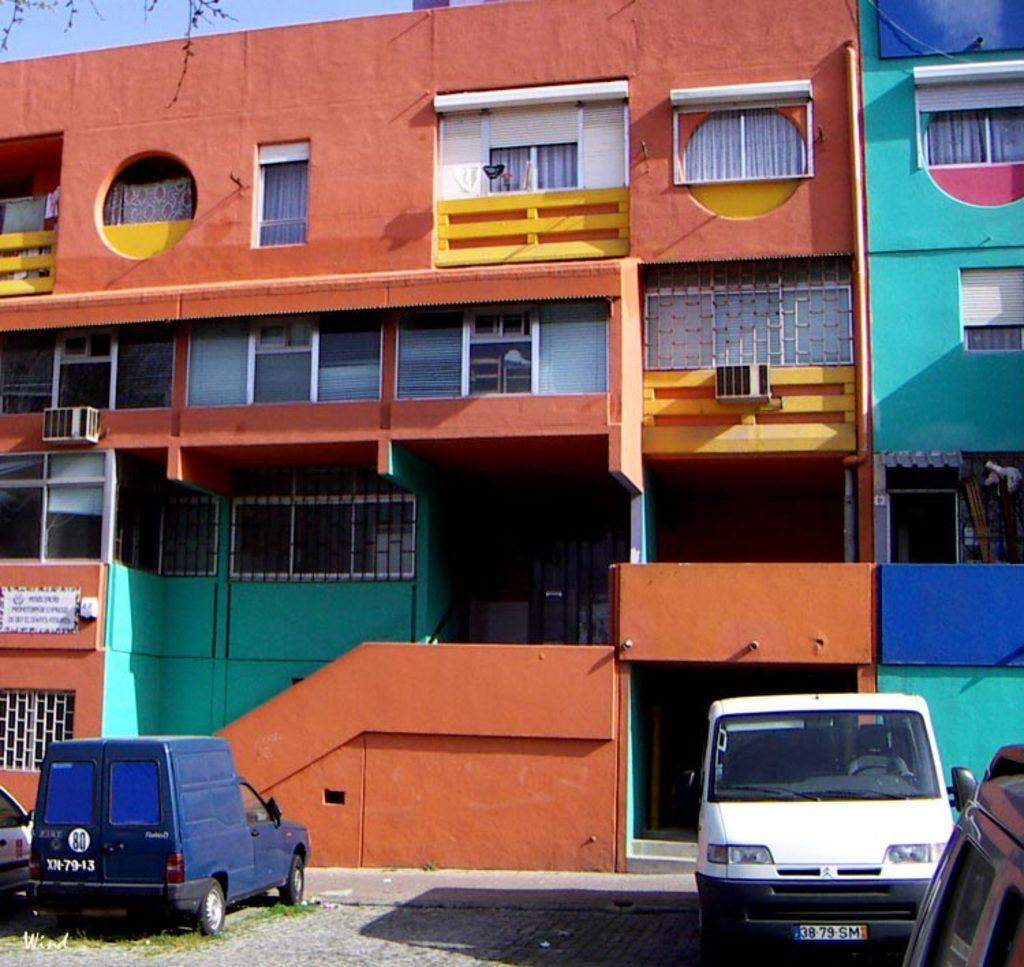What type of structures can be seen in the image? There are buildings in the image. What is the barrier-like object in the image? There is a fence in the image. What type of transportation is visible in the image? There are vehicles in the image. What part of the natural environment is visible in the image? The sky is visible in the image. How many beads are strung together on the fence in the image? There are no beads present on the fence in the image. What type of chairs are visible in the image? There are no chairs visible in the image. 